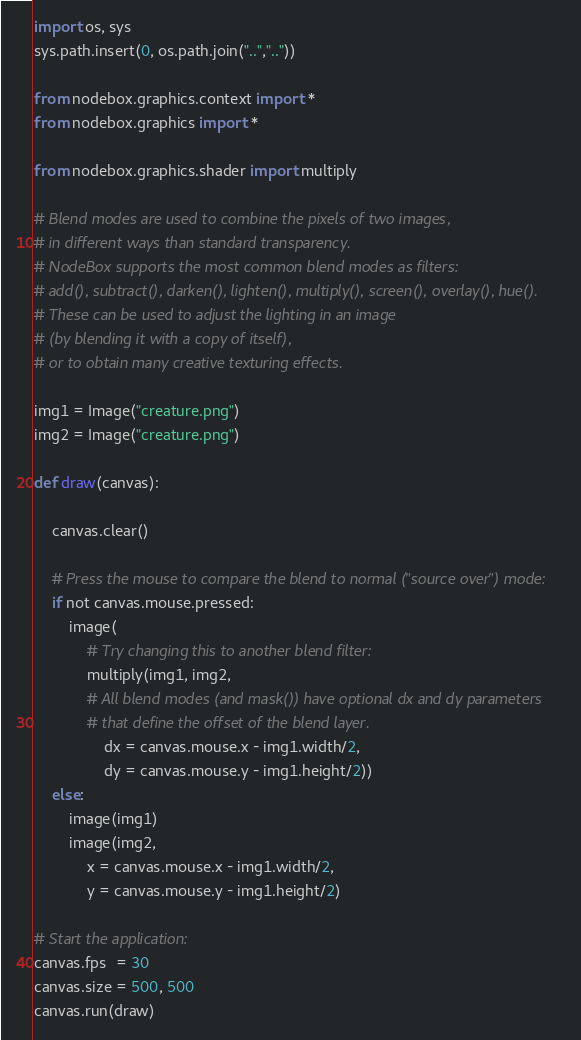Convert code to text. <code><loc_0><loc_0><loc_500><loc_500><_Python_>import os, sys
sys.path.insert(0, os.path.join("..",".."))

from nodebox.graphics.context import *
from nodebox.graphics import *

from nodebox.graphics.shader import multiply

# Blend modes are used to combine the pixels of two images,
# in different ways than standard transparency.
# NodeBox supports the most common blend modes as filters:
# add(), subtract(), darken(), lighten(), multiply(), screen(), overlay(), hue().
# These can be used to adjust the lighting in an image
# (by blending it with a copy of itself),
# or to obtain many creative texturing effects.

img1 = Image("creature.png")
img2 = Image("creature.png")

def draw(canvas):
    
    canvas.clear()
    
    # Press the mouse to compare the blend to normal ("source over") mode:
    if not canvas.mouse.pressed:
        image( 
            # Try changing this to another blend filter:
            multiply(img1, img2, 
            # All blend modes (and mask()) have optional dx and dy parameters
            # that define the offset of the blend layer.
                dx = canvas.mouse.x - img1.width/2, 
                dy = canvas.mouse.y - img1.height/2))
    else:
        image(img1)
        image(img2, 
            x = canvas.mouse.x - img1.width/2, 
            y = canvas.mouse.y - img1.height/2)

# Start the application:
canvas.fps  = 30
canvas.size = 500, 500
canvas.run(draw)</code> 